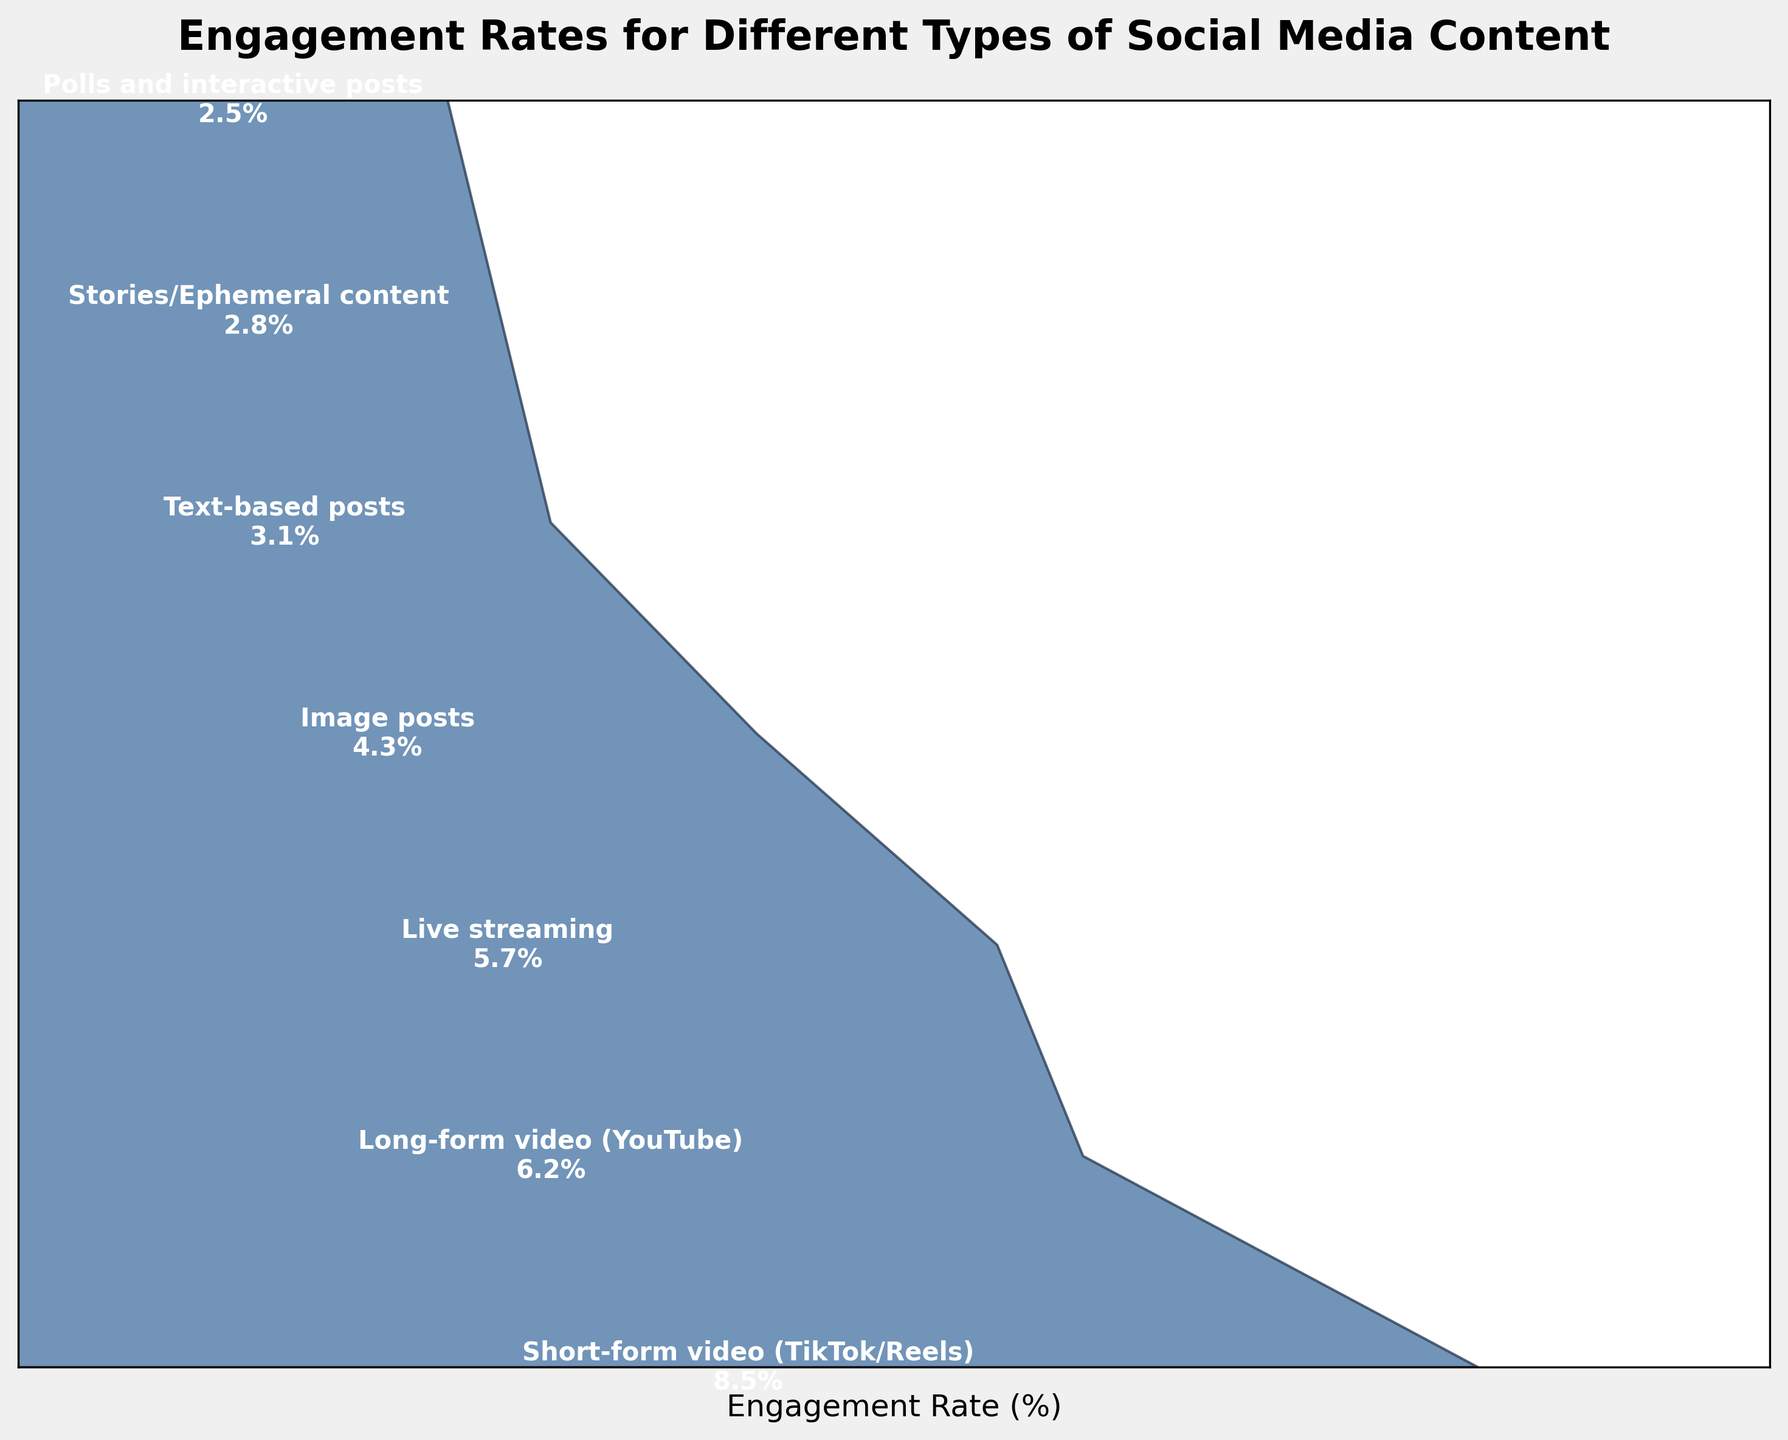What type of social media content has the highest engagement rate? Identify the content type with the highest value in the engagement rates column in the funnel chart. "Short-form video (TikTok/Reels)" has the highest engagement rate of 8.5%.
Answer: Short-form video (TikTok/Reels) What's the engagement rate for long-form videos on YouTube? Find "Long-form video (YouTube)" in the funnel chart and read its corresponding engagement rate. The engagement rate for long-form video (YouTube) is 6.2%.
Answer: 6.2% How much higher is the engagement rate for short-form video compared to live streaming? Look at the engagement rates for both short-form videos and live streaming. Subtract the engagement rate of live streaming (5.7%) from that of short-form video (8.5%). The difference is 8.5% - 5.7% = 2.8%.
Answer: 2.8% Which type of content has the lowest engagement rate? Observe the bottom of the funnel chart to identify the content type with the lowest engagement rate. "Polls and interactive posts" has the lowest engagement rate of 2.5%.
Answer: Polls and interactive posts What’s the average engagement rate for image posts, text-based posts, and stories? Add the engagement rates of image posts (4.3%), text-based posts (3.1%), and stories (2.8%) then divide by 3. (4.3% + 3.1% + 2.8%) / 3 ≈ 3.4%
Answer: 3.4% Which type of content has an engagement rate greater than 5% but less than 6%? Identify the content types in the funnel chart that fall between these values. "Live streaming" has an engagement rate of 5.7%, fitting this criteria.
Answer: Live streaming Compare the engagement rates of stories and polls. Which one is higher and by how much? Find the engagement rates of both stories (2.8%) and polls (2.5%) from the funnel chart. Subtract the engagement rate of polls from that of stories, 2.8% - 2.5% = 0.3%. Stories have a higher engagement rate by 0.3%.
Answer: Stories, 0.3% What is the combined engagement rate for long-form video and image posts? Add the engagement rates for long-form video (6.2%) and image posts (4.3%). The combined rate is 6.2% + 4.3% = 10.5%.
Answer: 10.5% What portion of the content types listed have an engagement rate below 4%? Count the content types with engagement rates below 4% (text-based posts, stories, polls) and divide by the total number of types listed (7). (3 / 7) = 0.4286 or about 43%.
Answer: 43% 